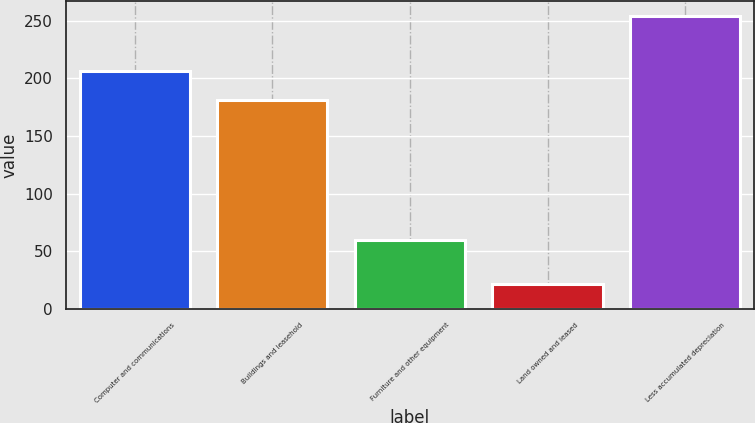Convert chart to OTSL. <chart><loc_0><loc_0><loc_500><loc_500><bar_chart><fcel>Computer and communications<fcel>Buildings and leasehold<fcel>Furniture and other equipment<fcel>Land owned and leased<fcel>Less accumulated depreciation<nl><fcel>206.3<fcel>181.5<fcel>59.8<fcel>21.5<fcel>254.3<nl></chart> 